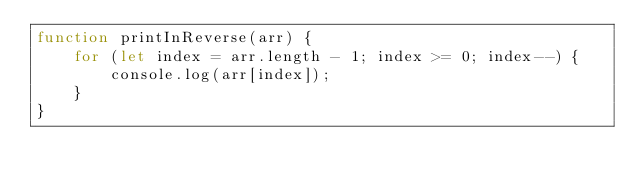Convert code to text. <code><loc_0><loc_0><loc_500><loc_500><_JavaScript_>function printInReverse(arr) {
    for (let index = arr.length - 1; index >= 0; index--) {
        console.log(arr[index]);
    }
}</code> 